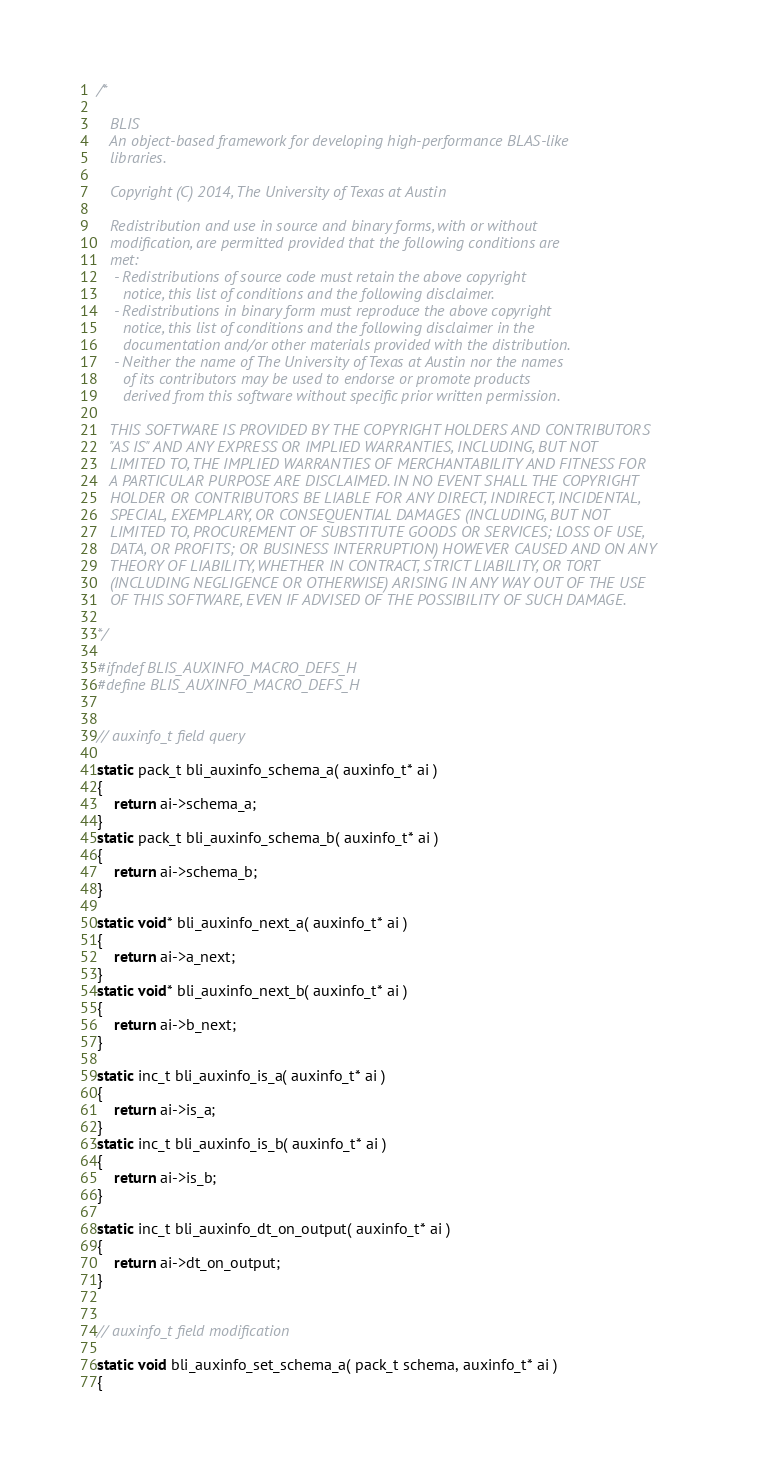<code> <loc_0><loc_0><loc_500><loc_500><_C_>/*

   BLIS    
   An object-based framework for developing high-performance BLAS-like
   libraries.

   Copyright (C) 2014, The University of Texas at Austin

   Redistribution and use in source and binary forms, with or without
   modification, are permitted provided that the following conditions are
   met:
    - Redistributions of source code must retain the above copyright
      notice, this list of conditions and the following disclaimer.
    - Redistributions in binary form must reproduce the above copyright
      notice, this list of conditions and the following disclaimer in the
      documentation and/or other materials provided with the distribution.
    - Neither the name of The University of Texas at Austin nor the names
      of its contributors may be used to endorse or promote products
      derived from this software without specific prior written permission.

   THIS SOFTWARE IS PROVIDED BY THE COPYRIGHT HOLDERS AND CONTRIBUTORS
   "AS IS" AND ANY EXPRESS OR IMPLIED WARRANTIES, INCLUDING, BUT NOT
   LIMITED TO, THE IMPLIED WARRANTIES OF MERCHANTABILITY AND FITNESS FOR
   A PARTICULAR PURPOSE ARE DISCLAIMED. IN NO EVENT SHALL THE COPYRIGHT
   HOLDER OR CONTRIBUTORS BE LIABLE FOR ANY DIRECT, INDIRECT, INCIDENTAL,
   SPECIAL, EXEMPLARY, OR CONSEQUENTIAL DAMAGES (INCLUDING, BUT NOT
   LIMITED TO, PROCUREMENT OF SUBSTITUTE GOODS OR SERVICES; LOSS OF USE,
   DATA, OR PROFITS; OR BUSINESS INTERRUPTION) HOWEVER CAUSED AND ON ANY
   THEORY OF LIABILITY, WHETHER IN CONTRACT, STRICT LIABILITY, OR TORT
   (INCLUDING NEGLIGENCE OR OTHERWISE) ARISING IN ANY WAY OUT OF THE USE
   OF THIS SOFTWARE, EVEN IF ADVISED OF THE POSSIBILITY OF SUCH DAMAGE.

*/

#ifndef BLIS_AUXINFO_MACRO_DEFS_H
#define BLIS_AUXINFO_MACRO_DEFS_H


// auxinfo_t field query

static pack_t bli_auxinfo_schema_a( auxinfo_t* ai )
{
	return ai->schema_a;
}
static pack_t bli_auxinfo_schema_b( auxinfo_t* ai )
{
	return ai->schema_b;
}

static void* bli_auxinfo_next_a( auxinfo_t* ai )
{
	return ai->a_next;
}
static void* bli_auxinfo_next_b( auxinfo_t* ai )
{
	return ai->b_next;
}

static inc_t bli_auxinfo_is_a( auxinfo_t* ai )
{
	return ai->is_a;
}
static inc_t bli_auxinfo_is_b( auxinfo_t* ai )
{
	return ai->is_b;
}

static inc_t bli_auxinfo_dt_on_output( auxinfo_t* ai )
{
	return ai->dt_on_output;
}


// auxinfo_t field modification

static void bli_auxinfo_set_schema_a( pack_t schema, auxinfo_t* ai )
{</code> 